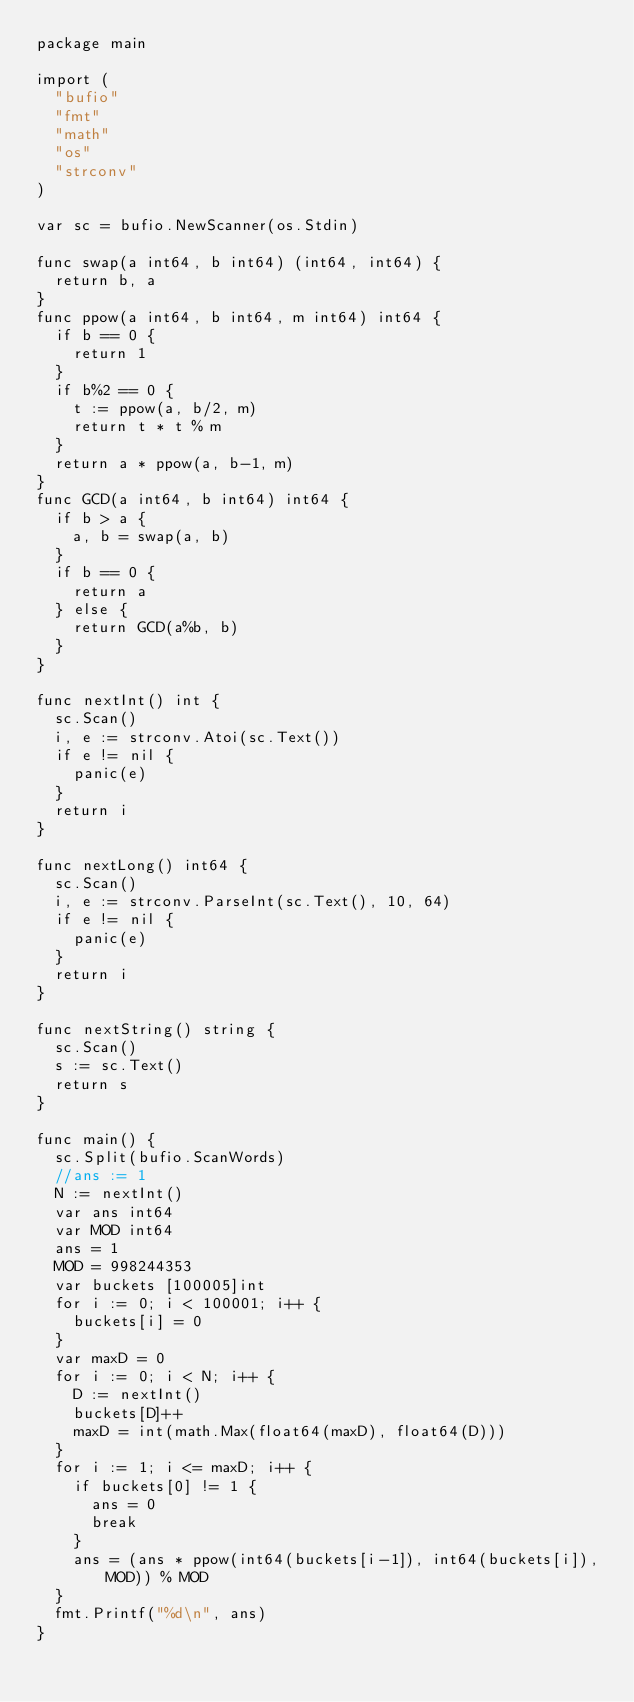Convert code to text. <code><loc_0><loc_0><loc_500><loc_500><_Go_>package main

import (
	"bufio"
	"fmt"
	"math"
	"os"
	"strconv"
)

var sc = bufio.NewScanner(os.Stdin)

func swap(a int64, b int64) (int64, int64) {
	return b, a
}
func ppow(a int64, b int64, m int64) int64 {
	if b == 0 {
		return 1
	}
	if b%2 == 0 {
		t := ppow(a, b/2, m)
		return t * t % m
	}
	return a * ppow(a, b-1, m)
}
func GCD(a int64, b int64) int64 {
	if b > a {
		a, b = swap(a, b)
	}
	if b == 0 {
		return a
	} else {
		return GCD(a%b, b)
	}
}

func nextInt() int {
	sc.Scan()
	i, e := strconv.Atoi(sc.Text())
	if e != nil {
		panic(e)
	}
	return i
}

func nextLong() int64 {
	sc.Scan()
	i, e := strconv.ParseInt(sc.Text(), 10, 64)
	if e != nil {
		panic(e)
	}
	return i
}

func nextString() string {
	sc.Scan()
	s := sc.Text()
	return s
}

func main() {
	sc.Split(bufio.ScanWords)
	//ans := 1
	N := nextInt()
	var ans int64
	var MOD int64
	ans = 1
	MOD = 998244353
	var buckets [100005]int
	for i := 0; i < 100001; i++ {
		buckets[i] = 0
	}
	var maxD = 0
	for i := 0; i < N; i++ {
		D := nextInt()
		buckets[D]++
		maxD = int(math.Max(float64(maxD), float64(D)))
	}
	for i := 1; i <= maxD; i++ {
		if buckets[0] != 1 {
			ans = 0
			break
		}
		ans = (ans * ppow(int64(buckets[i-1]), int64(buckets[i]), MOD)) % MOD
	}
	fmt.Printf("%d\n", ans)
}
</code> 